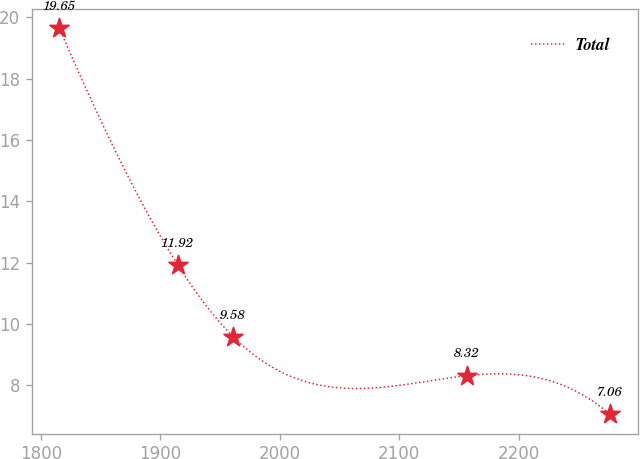Convert chart. <chart><loc_0><loc_0><loc_500><loc_500><line_chart><ecel><fcel>Total<nl><fcel>1815.5<fcel>19.65<nl><fcel>1914.83<fcel>11.92<nl><fcel>1961.23<fcel>9.58<nl><fcel>2156.74<fcel>8.32<nl><fcel>2276.2<fcel>7.06<nl></chart> 